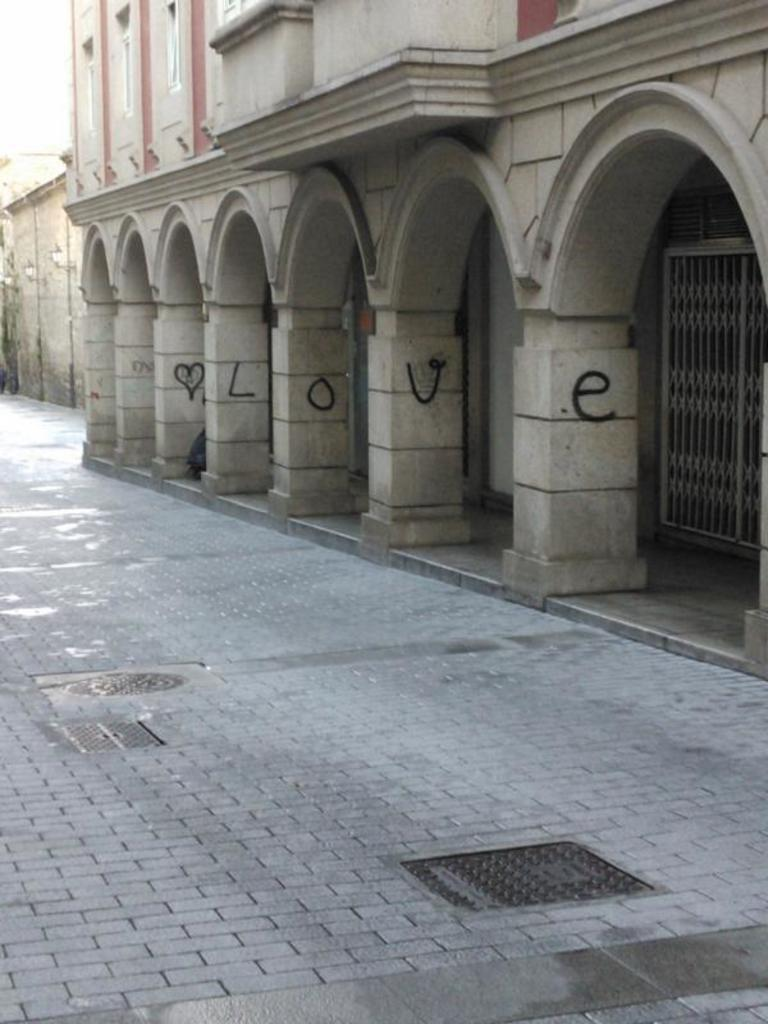What is the surface that can be seen in the image? There is a floor in the image. What can be seen in the distance in the image? There are buildings in the background of the image. What type of juice is being traded in the image? There is no juice or trade activity present in the image. 